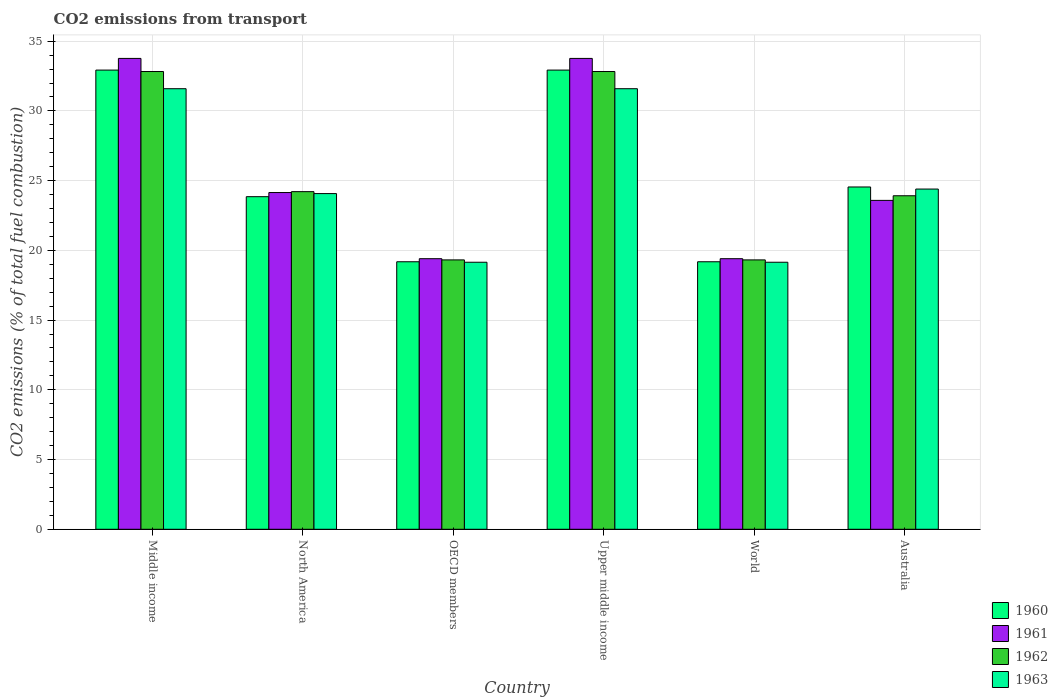How many different coloured bars are there?
Make the answer very short. 4. How many groups of bars are there?
Ensure brevity in your answer.  6. How many bars are there on the 2nd tick from the left?
Give a very brief answer. 4. What is the label of the 3rd group of bars from the left?
Your answer should be very brief. OECD members. In how many cases, is the number of bars for a given country not equal to the number of legend labels?
Offer a terse response. 0. What is the total CO2 emitted in 1962 in World?
Ensure brevity in your answer.  19.32. Across all countries, what is the maximum total CO2 emitted in 1962?
Offer a terse response. 32.82. Across all countries, what is the minimum total CO2 emitted in 1963?
Make the answer very short. 19.15. In which country was the total CO2 emitted in 1960 maximum?
Provide a succinct answer. Middle income. What is the total total CO2 emitted in 1961 in the graph?
Your response must be concise. 154.07. What is the difference between the total CO2 emitted in 1963 in North America and that in World?
Offer a very short reply. 4.92. What is the difference between the total CO2 emitted in 1963 in North America and the total CO2 emitted in 1960 in OECD members?
Keep it short and to the point. 4.89. What is the average total CO2 emitted in 1962 per country?
Give a very brief answer. 25.4. What is the difference between the total CO2 emitted of/in 1960 and total CO2 emitted of/in 1962 in World?
Your answer should be compact. -0.13. What is the ratio of the total CO2 emitted in 1963 in Middle income to that in OECD members?
Your response must be concise. 1.65. Is the total CO2 emitted in 1963 in Australia less than that in OECD members?
Your answer should be very brief. No. What is the difference between the highest and the second highest total CO2 emitted in 1961?
Your answer should be very brief. -9.62. What is the difference between the highest and the lowest total CO2 emitted in 1961?
Your answer should be very brief. 14.36. In how many countries, is the total CO2 emitted in 1962 greater than the average total CO2 emitted in 1962 taken over all countries?
Your response must be concise. 2. Is it the case that in every country, the sum of the total CO2 emitted in 1960 and total CO2 emitted in 1961 is greater than the sum of total CO2 emitted in 1963 and total CO2 emitted in 1962?
Provide a short and direct response. No. What does the 3rd bar from the right in World represents?
Give a very brief answer. 1961. How many bars are there?
Your answer should be very brief. 24. Are all the bars in the graph horizontal?
Provide a succinct answer. No. How many countries are there in the graph?
Offer a terse response. 6. What is the difference between two consecutive major ticks on the Y-axis?
Give a very brief answer. 5. Are the values on the major ticks of Y-axis written in scientific E-notation?
Provide a short and direct response. No. Does the graph contain any zero values?
Ensure brevity in your answer.  No. Where does the legend appear in the graph?
Provide a succinct answer. Bottom right. How many legend labels are there?
Ensure brevity in your answer.  4. What is the title of the graph?
Ensure brevity in your answer.  CO2 emissions from transport. What is the label or title of the Y-axis?
Give a very brief answer. CO2 emissions (% of total fuel combustion). What is the CO2 emissions (% of total fuel combustion) of 1960 in Middle income?
Your answer should be compact. 32.93. What is the CO2 emissions (% of total fuel combustion) in 1961 in Middle income?
Provide a short and direct response. 33.76. What is the CO2 emissions (% of total fuel combustion) of 1962 in Middle income?
Ensure brevity in your answer.  32.82. What is the CO2 emissions (% of total fuel combustion) of 1963 in Middle income?
Offer a terse response. 31.59. What is the CO2 emissions (% of total fuel combustion) of 1960 in North America?
Your answer should be compact. 23.85. What is the CO2 emissions (% of total fuel combustion) in 1961 in North America?
Offer a terse response. 24.15. What is the CO2 emissions (% of total fuel combustion) in 1962 in North America?
Your answer should be very brief. 24.21. What is the CO2 emissions (% of total fuel combustion) of 1963 in North America?
Give a very brief answer. 24.07. What is the CO2 emissions (% of total fuel combustion) in 1960 in OECD members?
Offer a very short reply. 19.18. What is the CO2 emissions (% of total fuel combustion) in 1961 in OECD members?
Keep it short and to the point. 19.4. What is the CO2 emissions (% of total fuel combustion) of 1962 in OECD members?
Your answer should be compact. 19.32. What is the CO2 emissions (% of total fuel combustion) of 1963 in OECD members?
Make the answer very short. 19.15. What is the CO2 emissions (% of total fuel combustion) of 1960 in Upper middle income?
Make the answer very short. 32.93. What is the CO2 emissions (% of total fuel combustion) in 1961 in Upper middle income?
Give a very brief answer. 33.76. What is the CO2 emissions (% of total fuel combustion) of 1962 in Upper middle income?
Give a very brief answer. 32.82. What is the CO2 emissions (% of total fuel combustion) in 1963 in Upper middle income?
Give a very brief answer. 31.59. What is the CO2 emissions (% of total fuel combustion) in 1960 in World?
Give a very brief answer. 19.18. What is the CO2 emissions (% of total fuel combustion) in 1961 in World?
Your answer should be compact. 19.4. What is the CO2 emissions (% of total fuel combustion) of 1962 in World?
Give a very brief answer. 19.32. What is the CO2 emissions (% of total fuel combustion) in 1963 in World?
Offer a terse response. 19.15. What is the CO2 emissions (% of total fuel combustion) in 1960 in Australia?
Give a very brief answer. 24.55. What is the CO2 emissions (% of total fuel combustion) in 1961 in Australia?
Provide a succinct answer. 23.59. What is the CO2 emissions (% of total fuel combustion) of 1962 in Australia?
Provide a short and direct response. 23.92. What is the CO2 emissions (% of total fuel combustion) in 1963 in Australia?
Offer a terse response. 24.4. Across all countries, what is the maximum CO2 emissions (% of total fuel combustion) in 1960?
Offer a terse response. 32.93. Across all countries, what is the maximum CO2 emissions (% of total fuel combustion) in 1961?
Give a very brief answer. 33.76. Across all countries, what is the maximum CO2 emissions (% of total fuel combustion) of 1962?
Your answer should be very brief. 32.82. Across all countries, what is the maximum CO2 emissions (% of total fuel combustion) of 1963?
Your answer should be compact. 31.59. Across all countries, what is the minimum CO2 emissions (% of total fuel combustion) in 1960?
Your response must be concise. 19.18. Across all countries, what is the minimum CO2 emissions (% of total fuel combustion) in 1961?
Offer a terse response. 19.4. Across all countries, what is the minimum CO2 emissions (% of total fuel combustion) in 1962?
Provide a succinct answer. 19.32. Across all countries, what is the minimum CO2 emissions (% of total fuel combustion) of 1963?
Your response must be concise. 19.15. What is the total CO2 emissions (% of total fuel combustion) of 1960 in the graph?
Make the answer very short. 152.62. What is the total CO2 emissions (% of total fuel combustion) in 1961 in the graph?
Make the answer very short. 154.07. What is the total CO2 emissions (% of total fuel combustion) in 1962 in the graph?
Give a very brief answer. 152.41. What is the total CO2 emissions (% of total fuel combustion) of 1963 in the graph?
Your answer should be compact. 149.95. What is the difference between the CO2 emissions (% of total fuel combustion) in 1960 in Middle income and that in North America?
Offer a terse response. 9.08. What is the difference between the CO2 emissions (% of total fuel combustion) of 1961 in Middle income and that in North America?
Your answer should be compact. 9.62. What is the difference between the CO2 emissions (% of total fuel combustion) in 1962 in Middle income and that in North America?
Make the answer very short. 8.61. What is the difference between the CO2 emissions (% of total fuel combustion) in 1963 in Middle income and that in North America?
Keep it short and to the point. 7.52. What is the difference between the CO2 emissions (% of total fuel combustion) in 1960 in Middle income and that in OECD members?
Give a very brief answer. 13.75. What is the difference between the CO2 emissions (% of total fuel combustion) in 1961 in Middle income and that in OECD members?
Ensure brevity in your answer.  14.36. What is the difference between the CO2 emissions (% of total fuel combustion) in 1962 in Middle income and that in OECD members?
Offer a terse response. 13.51. What is the difference between the CO2 emissions (% of total fuel combustion) in 1963 in Middle income and that in OECD members?
Offer a terse response. 12.44. What is the difference between the CO2 emissions (% of total fuel combustion) in 1960 in Middle income and that in Upper middle income?
Provide a short and direct response. 0. What is the difference between the CO2 emissions (% of total fuel combustion) of 1962 in Middle income and that in Upper middle income?
Your answer should be very brief. 0. What is the difference between the CO2 emissions (% of total fuel combustion) in 1960 in Middle income and that in World?
Make the answer very short. 13.75. What is the difference between the CO2 emissions (% of total fuel combustion) in 1961 in Middle income and that in World?
Offer a terse response. 14.36. What is the difference between the CO2 emissions (% of total fuel combustion) of 1962 in Middle income and that in World?
Provide a short and direct response. 13.51. What is the difference between the CO2 emissions (% of total fuel combustion) of 1963 in Middle income and that in World?
Offer a very short reply. 12.44. What is the difference between the CO2 emissions (% of total fuel combustion) of 1960 in Middle income and that in Australia?
Offer a terse response. 8.38. What is the difference between the CO2 emissions (% of total fuel combustion) of 1961 in Middle income and that in Australia?
Your answer should be compact. 10.18. What is the difference between the CO2 emissions (% of total fuel combustion) in 1962 in Middle income and that in Australia?
Keep it short and to the point. 8.91. What is the difference between the CO2 emissions (% of total fuel combustion) in 1963 in Middle income and that in Australia?
Your answer should be very brief. 7.2. What is the difference between the CO2 emissions (% of total fuel combustion) in 1960 in North America and that in OECD members?
Ensure brevity in your answer.  4.67. What is the difference between the CO2 emissions (% of total fuel combustion) in 1961 in North America and that in OECD members?
Make the answer very short. 4.74. What is the difference between the CO2 emissions (% of total fuel combustion) of 1962 in North America and that in OECD members?
Provide a short and direct response. 4.89. What is the difference between the CO2 emissions (% of total fuel combustion) of 1963 in North America and that in OECD members?
Your answer should be compact. 4.92. What is the difference between the CO2 emissions (% of total fuel combustion) in 1960 in North America and that in Upper middle income?
Your answer should be very brief. -9.08. What is the difference between the CO2 emissions (% of total fuel combustion) in 1961 in North America and that in Upper middle income?
Ensure brevity in your answer.  -9.62. What is the difference between the CO2 emissions (% of total fuel combustion) in 1962 in North America and that in Upper middle income?
Make the answer very short. -8.61. What is the difference between the CO2 emissions (% of total fuel combustion) of 1963 in North America and that in Upper middle income?
Your answer should be compact. -7.52. What is the difference between the CO2 emissions (% of total fuel combustion) in 1960 in North America and that in World?
Give a very brief answer. 4.67. What is the difference between the CO2 emissions (% of total fuel combustion) of 1961 in North America and that in World?
Provide a short and direct response. 4.74. What is the difference between the CO2 emissions (% of total fuel combustion) in 1962 in North America and that in World?
Give a very brief answer. 4.89. What is the difference between the CO2 emissions (% of total fuel combustion) in 1963 in North America and that in World?
Make the answer very short. 4.92. What is the difference between the CO2 emissions (% of total fuel combustion) in 1960 in North America and that in Australia?
Make the answer very short. -0.7. What is the difference between the CO2 emissions (% of total fuel combustion) of 1961 in North America and that in Australia?
Your answer should be very brief. 0.56. What is the difference between the CO2 emissions (% of total fuel combustion) of 1962 in North America and that in Australia?
Make the answer very short. 0.29. What is the difference between the CO2 emissions (% of total fuel combustion) in 1963 in North America and that in Australia?
Make the answer very short. -0.33. What is the difference between the CO2 emissions (% of total fuel combustion) of 1960 in OECD members and that in Upper middle income?
Your response must be concise. -13.75. What is the difference between the CO2 emissions (% of total fuel combustion) in 1961 in OECD members and that in Upper middle income?
Ensure brevity in your answer.  -14.36. What is the difference between the CO2 emissions (% of total fuel combustion) of 1962 in OECD members and that in Upper middle income?
Offer a very short reply. -13.51. What is the difference between the CO2 emissions (% of total fuel combustion) of 1963 in OECD members and that in Upper middle income?
Make the answer very short. -12.44. What is the difference between the CO2 emissions (% of total fuel combustion) in 1961 in OECD members and that in World?
Give a very brief answer. 0. What is the difference between the CO2 emissions (% of total fuel combustion) of 1962 in OECD members and that in World?
Your answer should be compact. 0. What is the difference between the CO2 emissions (% of total fuel combustion) in 1963 in OECD members and that in World?
Your answer should be compact. 0. What is the difference between the CO2 emissions (% of total fuel combustion) of 1960 in OECD members and that in Australia?
Keep it short and to the point. -5.36. What is the difference between the CO2 emissions (% of total fuel combustion) in 1961 in OECD members and that in Australia?
Your answer should be very brief. -4.18. What is the difference between the CO2 emissions (% of total fuel combustion) of 1962 in OECD members and that in Australia?
Your answer should be very brief. -4.6. What is the difference between the CO2 emissions (% of total fuel combustion) in 1963 in OECD members and that in Australia?
Offer a very short reply. -5.25. What is the difference between the CO2 emissions (% of total fuel combustion) of 1960 in Upper middle income and that in World?
Offer a very short reply. 13.75. What is the difference between the CO2 emissions (% of total fuel combustion) in 1961 in Upper middle income and that in World?
Your answer should be compact. 14.36. What is the difference between the CO2 emissions (% of total fuel combustion) in 1962 in Upper middle income and that in World?
Offer a very short reply. 13.51. What is the difference between the CO2 emissions (% of total fuel combustion) of 1963 in Upper middle income and that in World?
Offer a very short reply. 12.44. What is the difference between the CO2 emissions (% of total fuel combustion) of 1960 in Upper middle income and that in Australia?
Provide a short and direct response. 8.38. What is the difference between the CO2 emissions (% of total fuel combustion) in 1961 in Upper middle income and that in Australia?
Make the answer very short. 10.18. What is the difference between the CO2 emissions (% of total fuel combustion) in 1962 in Upper middle income and that in Australia?
Your answer should be compact. 8.91. What is the difference between the CO2 emissions (% of total fuel combustion) of 1963 in Upper middle income and that in Australia?
Your response must be concise. 7.2. What is the difference between the CO2 emissions (% of total fuel combustion) in 1960 in World and that in Australia?
Provide a short and direct response. -5.36. What is the difference between the CO2 emissions (% of total fuel combustion) in 1961 in World and that in Australia?
Offer a terse response. -4.18. What is the difference between the CO2 emissions (% of total fuel combustion) of 1962 in World and that in Australia?
Provide a short and direct response. -4.6. What is the difference between the CO2 emissions (% of total fuel combustion) of 1963 in World and that in Australia?
Your response must be concise. -5.25. What is the difference between the CO2 emissions (% of total fuel combustion) in 1960 in Middle income and the CO2 emissions (% of total fuel combustion) in 1961 in North America?
Offer a terse response. 8.78. What is the difference between the CO2 emissions (% of total fuel combustion) in 1960 in Middle income and the CO2 emissions (% of total fuel combustion) in 1962 in North America?
Your response must be concise. 8.72. What is the difference between the CO2 emissions (% of total fuel combustion) in 1960 in Middle income and the CO2 emissions (% of total fuel combustion) in 1963 in North America?
Your answer should be very brief. 8.86. What is the difference between the CO2 emissions (% of total fuel combustion) in 1961 in Middle income and the CO2 emissions (% of total fuel combustion) in 1962 in North America?
Your answer should be compact. 9.55. What is the difference between the CO2 emissions (% of total fuel combustion) in 1961 in Middle income and the CO2 emissions (% of total fuel combustion) in 1963 in North America?
Your answer should be very brief. 9.69. What is the difference between the CO2 emissions (% of total fuel combustion) of 1962 in Middle income and the CO2 emissions (% of total fuel combustion) of 1963 in North America?
Ensure brevity in your answer.  8.75. What is the difference between the CO2 emissions (% of total fuel combustion) of 1960 in Middle income and the CO2 emissions (% of total fuel combustion) of 1961 in OECD members?
Your answer should be very brief. 13.53. What is the difference between the CO2 emissions (% of total fuel combustion) in 1960 in Middle income and the CO2 emissions (% of total fuel combustion) in 1962 in OECD members?
Keep it short and to the point. 13.61. What is the difference between the CO2 emissions (% of total fuel combustion) of 1960 in Middle income and the CO2 emissions (% of total fuel combustion) of 1963 in OECD members?
Give a very brief answer. 13.78. What is the difference between the CO2 emissions (% of total fuel combustion) of 1961 in Middle income and the CO2 emissions (% of total fuel combustion) of 1962 in OECD members?
Make the answer very short. 14.45. What is the difference between the CO2 emissions (% of total fuel combustion) of 1961 in Middle income and the CO2 emissions (% of total fuel combustion) of 1963 in OECD members?
Your answer should be compact. 14.62. What is the difference between the CO2 emissions (% of total fuel combustion) of 1962 in Middle income and the CO2 emissions (% of total fuel combustion) of 1963 in OECD members?
Your answer should be very brief. 13.68. What is the difference between the CO2 emissions (% of total fuel combustion) of 1960 in Middle income and the CO2 emissions (% of total fuel combustion) of 1961 in Upper middle income?
Provide a succinct answer. -0.84. What is the difference between the CO2 emissions (% of total fuel combustion) of 1960 in Middle income and the CO2 emissions (% of total fuel combustion) of 1962 in Upper middle income?
Your response must be concise. 0.1. What is the difference between the CO2 emissions (% of total fuel combustion) of 1960 in Middle income and the CO2 emissions (% of total fuel combustion) of 1963 in Upper middle income?
Keep it short and to the point. 1.34. What is the difference between the CO2 emissions (% of total fuel combustion) of 1961 in Middle income and the CO2 emissions (% of total fuel combustion) of 1962 in Upper middle income?
Your answer should be very brief. 0.94. What is the difference between the CO2 emissions (% of total fuel combustion) in 1961 in Middle income and the CO2 emissions (% of total fuel combustion) in 1963 in Upper middle income?
Your answer should be compact. 2.17. What is the difference between the CO2 emissions (% of total fuel combustion) of 1962 in Middle income and the CO2 emissions (% of total fuel combustion) of 1963 in Upper middle income?
Provide a succinct answer. 1.23. What is the difference between the CO2 emissions (% of total fuel combustion) in 1960 in Middle income and the CO2 emissions (% of total fuel combustion) in 1961 in World?
Ensure brevity in your answer.  13.53. What is the difference between the CO2 emissions (% of total fuel combustion) of 1960 in Middle income and the CO2 emissions (% of total fuel combustion) of 1962 in World?
Offer a very short reply. 13.61. What is the difference between the CO2 emissions (% of total fuel combustion) in 1960 in Middle income and the CO2 emissions (% of total fuel combustion) in 1963 in World?
Give a very brief answer. 13.78. What is the difference between the CO2 emissions (% of total fuel combustion) of 1961 in Middle income and the CO2 emissions (% of total fuel combustion) of 1962 in World?
Provide a succinct answer. 14.45. What is the difference between the CO2 emissions (% of total fuel combustion) in 1961 in Middle income and the CO2 emissions (% of total fuel combustion) in 1963 in World?
Your answer should be compact. 14.62. What is the difference between the CO2 emissions (% of total fuel combustion) in 1962 in Middle income and the CO2 emissions (% of total fuel combustion) in 1963 in World?
Provide a succinct answer. 13.68. What is the difference between the CO2 emissions (% of total fuel combustion) of 1960 in Middle income and the CO2 emissions (% of total fuel combustion) of 1961 in Australia?
Your answer should be very brief. 9.34. What is the difference between the CO2 emissions (% of total fuel combustion) of 1960 in Middle income and the CO2 emissions (% of total fuel combustion) of 1962 in Australia?
Your answer should be very brief. 9.01. What is the difference between the CO2 emissions (% of total fuel combustion) in 1960 in Middle income and the CO2 emissions (% of total fuel combustion) in 1963 in Australia?
Provide a succinct answer. 8.53. What is the difference between the CO2 emissions (% of total fuel combustion) of 1961 in Middle income and the CO2 emissions (% of total fuel combustion) of 1962 in Australia?
Provide a short and direct response. 9.85. What is the difference between the CO2 emissions (% of total fuel combustion) of 1961 in Middle income and the CO2 emissions (% of total fuel combustion) of 1963 in Australia?
Provide a short and direct response. 9.37. What is the difference between the CO2 emissions (% of total fuel combustion) of 1962 in Middle income and the CO2 emissions (% of total fuel combustion) of 1963 in Australia?
Your answer should be very brief. 8.43. What is the difference between the CO2 emissions (% of total fuel combustion) in 1960 in North America and the CO2 emissions (% of total fuel combustion) in 1961 in OECD members?
Keep it short and to the point. 4.45. What is the difference between the CO2 emissions (% of total fuel combustion) in 1960 in North America and the CO2 emissions (% of total fuel combustion) in 1962 in OECD members?
Provide a short and direct response. 4.53. What is the difference between the CO2 emissions (% of total fuel combustion) of 1960 in North America and the CO2 emissions (% of total fuel combustion) of 1963 in OECD members?
Offer a terse response. 4.7. What is the difference between the CO2 emissions (% of total fuel combustion) in 1961 in North America and the CO2 emissions (% of total fuel combustion) in 1962 in OECD members?
Ensure brevity in your answer.  4.83. What is the difference between the CO2 emissions (% of total fuel combustion) of 1961 in North America and the CO2 emissions (% of total fuel combustion) of 1963 in OECD members?
Your answer should be compact. 5. What is the difference between the CO2 emissions (% of total fuel combustion) in 1962 in North America and the CO2 emissions (% of total fuel combustion) in 1963 in OECD members?
Offer a very short reply. 5.06. What is the difference between the CO2 emissions (% of total fuel combustion) of 1960 in North America and the CO2 emissions (% of total fuel combustion) of 1961 in Upper middle income?
Ensure brevity in your answer.  -9.91. What is the difference between the CO2 emissions (% of total fuel combustion) of 1960 in North America and the CO2 emissions (% of total fuel combustion) of 1962 in Upper middle income?
Your answer should be very brief. -8.97. What is the difference between the CO2 emissions (% of total fuel combustion) in 1960 in North America and the CO2 emissions (% of total fuel combustion) in 1963 in Upper middle income?
Keep it short and to the point. -7.74. What is the difference between the CO2 emissions (% of total fuel combustion) in 1961 in North America and the CO2 emissions (% of total fuel combustion) in 1962 in Upper middle income?
Offer a terse response. -8.68. What is the difference between the CO2 emissions (% of total fuel combustion) in 1961 in North America and the CO2 emissions (% of total fuel combustion) in 1963 in Upper middle income?
Make the answer very short. -7.45. What is the difference between the CO2 emissions (% of total fuel combustion) in 1962 in North America and the CO2 emissions (% of total fuel combustion) in 1963 in Upper middle income?
Give a very brief answer. -7.38. What is the difference between the CO2 emissions (% of total fuel combustion) in 1960 in North America and the CO2 emissions (% of total fuel combustion) in 1961 in World?
Your response must be concise. 4.45. What is the difference between the CO2 emissions (% of total fuel combustion) of 1960 in North America and the CO2 emissions (% of total fuel combustion) of 1962 in World?
Keep it short and to the point. 4.53. What is the difference between the CO2 emissions (% of total fuel combustion) of 1960 in North America and the CO2 emissions (% of total fuel combustion) of 1963 in World?
Offer a very short reply. 4.7. What is the difference between the CO2 emissions (% of total fuel combustion) in 1961 in North America and the CO2 emissions (% of total fuel combustion) in 1962 in World?
Give a very brief answer. 4.83. What is the difference between the CO2 emissions (% of total fuel combustion) of 1961 in North America and the CO2 emissions (% of total fuel combustion) of 1963 in World?
Keep it short and to the point. 5. What is the difference between the CO2 emissions (% of total fuel combustion) of 1962 in North America and the CO2 emissions (% of total fuel combustion) of 1963 in World?
Offer a terse response. 5.06. What is the difference between the CO2 emissions (% of total fuel combustion) in 1960 in North America and the CO2 emissions (% of total fuel combustion) in 1961 in Australia?
Your answer should be very brief. 0.27. What is the difference between the CO2 emissions (% of total fuel combustion) of 1960 in North America and the CO2 emissions (% of total fuel combustion) of 1962 in Australia?
Give a very brief answer. -0.07. What is the difference between the CO2 emissions (% of total fuel combustion) in 1960 in North America and the CO2 emissions (% of total fuel combustion) in 1963 in Australia?
Keep it short and to the point. -0.55. What is the difference between the CO2 emissions (% of total fuel combustion) in 1961 in North America and the CO2 emissions (% of total fuel combustion) in 1962 in Australia?
Ensure brevity in your answer.  0.23. What is the difference between the CO2 emissions (% of total fuel combustion) of 1961 in North America and the CO2 emissions (% of total fuel combustion) of 1963 in Australia?
Your answer should be very brief. -0.25. What is the difference between the CO2 emissions (% of total fuel combustion) of 1962 in North America and the CO2 emissions (% of total fuel combustion) of 1963 in Australia?
Keep it short and to the point. -0.19. What is the difference between the CO2 emissions (% of total fuel combustion) in 1960 in OECD members and the CO2 emissions (% of total fuel combustion) in 1961 in Upper middle income?
Keep it short and to the point. -14.58. What is the difference between the CO2 emissions (% of total fuel combustion) of 1960 in OECD members and the CO2 emissions (% of total fuel combustion) of 1962 in Upper middle income?
Ensure brevity in your answer.  -13.64. What is the difference between the CO2 emissions (% of total fuel combustion) in 1960 in OECD members and the CO2 emissions (% of total fuel combustion) in 1963 in Upper middle income?
Your response must be concise. -12.41. What is the difference between the CO2 emissions (% of total fuel combustion) in 1961 in OECD members and the CO2 emissions (% of total fuel combustion) in 1962 in Upper middle income?
Ensure brevity in your answer.  -13.42. What is the difference between the CO2 emissions (% of total fuel combustion) in 1961 in OECD members and the CO2 emissions (% of total fuel combustion) in 1963 in Upper middle income?
Provide a succinct answer. -12.19. What is the difference between the CO2 emissions (% of total fuel combustion) in 1962 in OECD members and the CO2 emissions (% of total fuel combustion) in 1963 in Upper middle income?
Offer a very short reply. -12.28. What is the difference between the CO2 emissions (% of total fuel combustion) in 1960 in OECD members and the CO2 emissions (% of total fuel combustion) in 1961 in World?
Make the answer very short. -0.22. What is the difference between the CO2 emissions (% of total fuel combustion) in 1960 in OECD members and the CO2 emissions (% of total fuel combustion) in 1962 in World?
Your answer should be compact. -0.13. What is the difference between the CO2 emissions (% of total fuel combustion) in 1960 in OECD members and the CO2 emissions (% of total fuel combustion) in 1963 in World?
Keep it short and to the point. 0.03. What is the difference between the CO2 emissions (% of total fuel combustion) in 1961 in OECD members and the CO2 emissions (% of total fuel combustion) in 1962 in World?
Your answer should be compact. 0.09. What is the difference between the CO2 emissions (% of total fuel combustion) of 1961 in OECD members and the CO2 emissions (% of total fuel combustion) of 1963 in World?
Offer a very short reply. 0.25. What is the difference between the CO2 emissions (% of total fuel combustion) in 1962 in OECD members and the CO2 emissions (% of total fuel combustion) in 1963 in World?
Ensure brevity in your answer.  0.17. What is the difference between the CO2 emissions (% of total fuel combustion) in 1960 in OECD members and the CO2 emissions (% of total fuel combustion) in 1961 in Australia?
Ensure brevity in your answer.  -4.4. What is the difference between the CO2 emissions (% of total fuel combustion) in 1960 in OECD members and the CO2 emissions (% of total fuel combustion) in 1962 in Australia?
Make the answer very short. -4.73. What is the difference between the CO2 emissions (% of total fuel combustion) in 1960 in OECD members and the CO2 emissions (% of total fuel combustion) in 1963 in Australia?
Your answer should be compact. -5.21. What is the difference between the CO2 emissions (% of total fuel combustion) of 1961 in OECD members and the CO2 emissions (% of total fuel combustion) of 1962 in Australia?
Keep it short and to the point. -4.51. What is the difference between the CO2 emissions (% of total fuel combustion) in 1961 in OECD members and the CO2 emissions (% of total fuel combustion) in 1963 in Australia?
Make the answer very short. -4.99. What is the difference between the CO2 emissions (% of total fuel combustion) of 1962 in OECD members and the CO2 emissions (% of total fuel combustion) of 1963 in Australia?
Your answer should be compact. -5.08. What is the difference between the CO2 emissions (% of total fuel combustion) of 1960 in Upper middle income and the CO2 emissions (% of total fuel combustion) of 1961 in World?
Make the answer very short. 13.53. What is the difference between the CO2 emissions (% of total fuel combustion) in 1960 in Upper middle income and the CO2 emissions (% of total fuel combustion) in 1962 in World?
Make the answer very short. 13.61. What is the difference between the CO2 emissions (% of total fuel combustion) in 1960 in Upper middle income and the CO2 emissions (% of total fuel combustion) in 1963 in World?
Offer a very short reply. 13.78. What is the difference between the CO2 emissions (% of total fuel combustion) in 1961 in Upper middle income and the CO2 emissions (% of total fuel combustion) in 1962 in World?
Your answer should be very brief. 14.45. What is the difference between the CO2 emissions (% of total fuel combustion) in 1961 in Upper middle income and the CO2 emissions (% of total fuel combustion) in 1963 in World?
Give a very brief answer. 14.62. What is the difference between the CO2 emissions (% of total fuel combustion) in 1962 in Upper middle income and the CO2 emissions (% of total fuel combustion) in 1963 in World?
Provide a short and direct response. 13.68. What is the difference between the CO2 emissions (% of total fuel combustion) in 1960 in Upper middle income and the CO2 emissions (% of total fuel combustion) in 1961 in Australia?
Ensure brevity in your answer.  9.34. What is the difference between the CO2 emissions (% of total fuel combustion) of 1960 in Upper middle income and the CO2 emissions (% of total fuel combustion) of 1962 in Australia?
Provide a succinct answer. 9.01. What is the difference between the CO2 emissions (% of total fuel combustion) of 1960 in Upper middle income and the CO2 emissions (% of total fuel combustion) of 1963 in Australia?
Ensure brevity in your answer.  8.53. What is the difference between the CO2 emissions (% of total fuel combustion) in 1961 in Upper middle income and the CO2 emissions (% of total fuel combustion) in 1962 in Australia?
Offer a very short reply. 9.85. What is the difference between the CO2 emissions (% of total fuel combustion) of 1961 in Upper middle income and the CO2 emissions (% of total fuel combustion) of 1963 in Australia?
Ensure brevity in your answer.  9.37. What is the difference between the CO2 emissions (% of total fuel combustion) of 1962 in Upper middle income and the CO2 emissions (% of total fuel combustion) of 1963 in Australia?
Make the answer very short. 8.43. What is the difference between the CO2 emissions (% of total fuel combustion) in 1960 in World and the CO2 emissions (% of total fuel combustion) in 1961 in Australia?
Provide a succinct answer. -4.4. What is the difference between the CO2 emissions (% of total fuel combustion) in 1960 in World and the CO2 emissions (% of total fuel combustion) in 1962 in Australia?
Offer a terse response. -4.73. What is the difference between the CO2 emissions (% of total fuel combustion) in 1960 in World and the CO2 emissions (% of total fuel combustion) in 1963 in Australia?
Offer a terse response. -5.21. What is the difference between the CO2 emissions (% of total fuel combustion) in 1961 in World and the CO2 emissions (% of total fuel combustion) in 1962 in Australia?
Give a very brief answer. -4.51. What is the difference between the CO2 emissions (% of total fuel combustion) in 1961 in World and the CO2 emissions (% of total fuel combustion) in 1963 in Australia?
Offer a terse response. -4.99. What is the difference between the CO2 emissions (% of total fuel combustion) in 1962 in World and the CO2 emissions (% of total fuel combustion) in 1963 in Australia?
Your answer should be compact. -5.08. What is the average CO2 emissions (% of total fuel combustion) in 1960 per country?
Make the answer very short. 25.44. What is the average CO2 emissions (% of total fuel combustion) of 1961 per country?
Your answer should be very brief. 25.68. What is the average CO2 emissions (% of total fuel combustion) in 1962 per country?
Your response must be concise. 25.4. What is the average CO2 emissions (% of total fuel combustion) of 1963 per country?
Keep it short and to the point. 24.99. What is the difference between the CO2 emissions (% of total fuel combustion) in 1960 and CO2 emissions (% of total fuel combustion) in 1961 in Middle income?
Offer a terse response. -0.84. What is the difference between the CO2 emissions (% of total fuel combustion) in 1960 and CO2 emissions (% of total fuel combustion) in 1962 in Middle income?
Make the answer very short. 0.1. What is the difference between the CO2 emissions (% of total fuel combustion) in 1960 and CO2 emissions (% of total fuel combustion) in 1963 in Middle income?
Offer a very short reply. 1.34. What is the difference between the CO2 emissions (% of total fuel combustion) of 1961 and CO2 emissions (% of total fuel combustion) of 1962 in Middle income?
Offer a terse response. 0.94. What is the difference between the CO2 emissions (% of total fuel combustion) of 1961 and CO2 emissions (% of total fuel combustion) of 1963 in Middle income?
Offer a terse response. 2.17. What is the difference between the CO2 emissions (% of total fuel combustion) of 1962 and CO2 emissions (% of total fuel combustion) of 1963 in Middle income?
Provide a short and direct response. 1.23. What is the difference between the CO2 emissions (% of total fuel combustion) of 1960 and CO2 emissions (% of total fuel combustion) of 1961 in North America?
Your response must be concise. -0.3. What is the difference between the CO2 emissions (% of total fuel combustion) in 1960 and CO2 emissions (% of total fuel combustion) in 1962 in North America?
Your answer should be compact. -0.36. What is the difference between the CO2 emissions (% of total fuel combustion) of 1960 and CO2 emissions (% of total fuel combustion) of 1963 in North America?
Your response must be concise. -0.22. What is the difference between the CO2 emissions (% of total fuel combustion) of 1961 and CO2 emissions (% of total fuel combustion) of 1962 in North America?
Provide a succinct answer. -0.06. What is the difference between the CO2 emissions (% of total fuel combustion) of 1961 and CO2 emissions (% of total fuel combustion) of 1963 in North America?
Your response must be concise. 0.07. What is the difference between the CO2 emissions (% of total fuel combustion) of 1962 and CO2 emissions (% of total fuel combustion) of 1963 in North America?
Make the answer very short. 0.14. What is the difference between the CO2 emissions (% of total fuel combustion) in 1960 and CO2 emissions (% of total fuel combustion) in 1961 in OECD members?
Your answer should be compact. -0.22. What is the difference between the CO2 emissions (% of total fuel combustion) in 1960 and CO2 emissions (% of total fuel combustion) in 1962 in OECD members?
Provide a succinct answer. -0.13. What is the difference between the CO2 emissions (% of total fuel combustion) in 1960 and CO2 emissions (% of total fuel combustion) in 1963 in OECD members?
Your response must be concise. 0.03. What is the difference between the CO2 emissions (% of total fuel combustion) in 1961 and CO2 emissions (% of total fuel combustion) in 1962 in OECD members?
Keep it short and to the point. 0.09. What is the difference between the CO2 emissions (% of total fuel combustion) in 1961 and CO2 emissions (% of total fuel combustion) in 1963 in OECD members?
Make the answer very short. 0.25. What is the difference between the CO2 emissions (% of total fuel combustion) in 1962 and CO2 emissions (% of total fuel combustion) in 1963 in OECD members?
Make the answer very short. 0.17. What is the difference between the CO2 emissions (% of total fuel combustion) in 1960 and CO2 emissions (% of total fuel combustion) in 1961 in Upper middle income?
Offer a terse response. -0.84. What is the difference between the CO2 emissions (% of total fuel combustion) in 1960 and CO2 emissions (% of total fuel combustion) in 1962 in Upper middle income?
Offer a very short reply. 0.1. What is the difference between the CO2 emissions (% of total fuel combustion) of 1960 and CO2 emissions (% of total fuel combustion) of 1963 in Upper middle income?
Your response must be concise. 1.34. What is the difference between the CO2 emissions (% of total fuel combustion) in 1961 and CO2 emissions (% of total fuel combustion) in 1962 in Upper middle income?
Offer a very short reply. 0.94. What is the difference between the CO2 emissions (% of total fuel combustion) in 1961 and CO2 emissions (% of total fuel combustion) in 1963 in Upper middle income?
Make the answer very short. 2.17. What is the difference between the CO2 emissions (% of total fuel combustion) in 1962 and CO2 emissions (% of total fuel combustion) in 1963 in Upper middle income?
Your answer should be very brief. 1.23. What is the difference between the CO2 emissions (% of total fuel combustion) in 1960 and CO2 emissions (% of total fuel combustion) in 1961 in World?
Your response must be concise. -0.22. What is the difference between the CO2 emissions (% of total fuel combustion) of 1960 and CO2 emissions (% of total fuel combustion) of 1962 in World?
Offer a very short reply. -0.13. What is the difference between the CO2 emissions (% of total fuel combustion) in 1960 and CO2 emissions (% of total fuel combustion) in 1963 in World?
Provide a succinct answer. 0.03. What is the difference between the CO2 emissions (% of total fuel combustion) in 1961 and CO2 emissions (% of total fuel combustion) in 1962 in World?
Offer a very short reply. 0.09. What is the difference between the CO2 emissions (% of total fuel combustion) in 1961 and CO2 emissions (% of total fuel combustion) in 1963 in World?
Your response must be concise. 0.25. What is the difference between the CO2 emissions (% of total fuel combustion) in 1962 and CO2 emissions (% of total fuel combustion) in 1963 in World?
Provide a succinct answer. 0.17. What is the difference between the CO2 emissions (% of total fuel combustion) in 1960 and CO2 emissions (% of total fuel combustion) in 1961 in Australia?
Your answer should be very brief. 0.96. What is the difference between the CO2 emissions (% of total fuel combustion) in 1960 and CO2 emissions (% of total fuel combustion) in 1962 in Australia?
Your answer should be compact. 0.63. What is the difference between the CO2 emissions (% of total fuel combustion) of 1960 and CO2 emissions (% of total fuel combustion) of 1963 in Australia?
Offer a very short reply. 0.15. What is the difference between the CO2 emissions (% of total fuel combustion) of 1961 and CO2 emissions (% of total fuel combustion) of 1962 in Australia?
Provide a short and direct response. -0.33. What is the difference between the CO2 emissions (% of total fuel combustion) of 1961 and CO2 emissions (% of total fuel combustion) of 1963 in Australia?
Keep it short and to the point. -0.81. What is the difference between the CO2 emissions (% of total fuel combustion) in 1962 and CO2 emissions (% of total fuel combustion) in 1963 in Australia?
Give a very brief answer. -0.48. What is the ratio of the CO2 emissions (% of total fuel combustion) in 1960 in Middle income to that in North America?
Offer a terse response. 1.38. What is the ratio of the CO2 emissions (% of total fuel combustion) of 1961 in Middle income to that in North America?
Provide a short and direct response. 1.4. What is the ratio of the CO2 emissions (% of total fuel combustion) of 1962 in Middle income to that in North America?
Offer a very short reply. 1.36. What is the ratio of the CO2 emissions (% of total fuel combustion) in 1963 in Middle income to that in North America?
Your answer should be compact. 1.31. What is the ratio of the CO2 emissions (% of total fuel combustion) in 1960 in Middle income to that in OECD members?
Make the answer very short. 1.72. What is the ratio of the CO2 emissions (% of total fuel combustion) in 1961 in Middle income to that in OECD members?
Provide a succinct answer. 1.74. What is the ratio of the CO2 emissions (% of total fuel combustion) in 1962 in Middle income to that in OECD members?
Ensure brevity in your answer.  1.7. What is the ratio of the CO2 emissions (% of total fuel combustion) in 1963 in Middle income to that in OECD members?
Provide a succinct answer. 1.65. What is the ratio of the CO2 emissions (% of total fuel combustion) of 1960 in Middle income to that in Upper middle income?
Provide a short and direct response. 1. What is the ratio of the CO2 emissions (% of total fuel combustion) of 1961 in Middle income to that in Upper middle income?
Offer a terse response. 1. What is the ratio of the CO2 emissions (% of total fuel combustion) of 1963 in Middle income to that in Upper middle income?
Keep it short and to the point. 1. What is the ratio of the CO2 emissions (% of total fuel combustion) of 1960 in Middle income to that in World?
Provide a succinct answer. 1.72. What is the ratio of the CO2 emissions (% of total fuel combustion) in 1961 in Middle income to that in World?
Give a very brief answer. 1.74. What is the ratio of the CO2 emissions (% of total fuel combustion) in 1962 in Middle income to that in World?
Provide a succinct answer. 1.7. What is the ratio of the CO2 emissions (% of total fuel combustion) in 1963 in Middle income to that in World?
Keep it short and to the point. 1.65. What is the ratio of the CO2 emissions (% of total fuel combustion) in 1960 in Middle income to that in Australia?
Keep it short and to the point. 1.34. What is the ratio of the CO2 emissions (% of total fuel combustion) in 1961 in Middle income to that in Australia?
Provide a succinct answer. 1.43. What is the ratio of the CO2 emissions (% of total fuel combustion) of 1962 in Middle income to that in Australia?
Keep it short and to the point. 1.37. What is the ratio of the CO2 emissions (% of total fuel combustion) of 1963 in Middle income to that in Australia?
Ensure brevity in your answer.  1.29. What is the ratio of the CO2 emissions (% of total fuel combustion) in 1960 in North America to that in OECD members?
Your answer should be very brief. 1.24. What is the ratio of the CO2 emissions (% of total fuel combustion) of 1961 in North America to that in OECD members?
Ensure brevity in your answer.  1.24. What is the ratio of the CO2 emissions (% of total fuel combustion) of 1962 in North America to that in OECD members?
Your response must be concise. 1.25. What is the ratio of the CO2 emissions (% of total fuel combustion) in 1963 in North America to that in OECD members?
Give a very brief answer. 1.26. What is the ratio of the CO2 emissions (% of total fuel combustion) of 1960 in North America to that in Upper middle income?
Offer a very short reply. 0.72. What is the ratio of the CO2 emissions (% of total fuel combustion) in 1961 in North America to that in Upper middle income?
Ensure brevity in your answer.  0.72. What is the ratio of the CO2 emissions (% of total fuel combustion) in 1962 in North America to that in Upper middle income?
Give a very brief answer. 0.74. What is the ratio of the CO2 emissions (% of total fuel combustion) of 1963 in North America to that in Upper middle income?
Give a very brief answer. 0.76. What is the ratio of the CO2 emissions (% of total fuel combustion) in 1960 in North America to that in World?
Give a very brief answer. 1.24. What is the ratio of the CO2 emissions (% of total fuel combustion) of 1961 in North America to that in World?
Your answer should be compact. 1.24. What is the ratio of the CO2 emissions (% of total fuel combustion) of 1962 in North America to that in World?
Provide a succinct answer. 1.25. What is the ratio of the CO2 emissions (% of total fuel combustion) of 1963 in North America to that in World?
Give a very brief answer. 1.26. What is the ratio of the CO2 emissions (% of total fuel combustion) of 1960 in North America to that in Australia?
Offer a terse response. 0.97. What is the ratio of the CO2 emissions (% of total fuel combustion) of 1961 in North America to that in Australia?
Your answer should be very brief. 1.02. What is the ratio of the CO2 emissions (% of total fuel combustion) in 1962 in North America to that in Australia?
Offer a terse response. 1.01. What is the ratio of the CO2 emissions (% of total fuel combustion) of 1963 in North America to that in Australia?
Make the answer very short. 0.99. What is the ratio of the CO2 emissions (% of total fuel combustion) of 1960 in OECD members to that in Upper middle income?
Keep it short and to the point. 0.58. What is the ratio of the CO2 emissions (% of total fuel combustion) of 1961 in OECD members to that in Upper middle income?
Your answer should be compact. 0.57. What is the ratio of the CO2 emissions (% of total fuel combustion) of 1962 in OECD members to that in Upper middle income?
Offer a terse response. 0.59. What is the ratio of the CO2 emissions (% of total fuel combustion) in 1963 in OECD members to that in Upper middle income?
Your answer should be compact. 0.61. What is the ratio of the CO2 emissions (% of total fuel combustion) of 1960 in OECD members to that in World?
Make the answer very short. 1. What is the ratio of the CO2 emissions (% of total fuel combustion) in 1961 in OECD members to that in World?
Provide a short and direct response. 1. What is the ratio of the CO2 emissions (% of total fuel combustion) in 1962 in OECD members to that in World?
Provide a succinct answer. 1. What is the ratio of the CO2 emissions (% of total fuel combustion) in 1960 in OECD members to that in Australia?
Your response must be concise. 0.78. What is the ratio of the CO2 emissions (% of total fuel combustion) in 1961 in OECD members to that in Australia?
Give a very brief answer. 0.82. What is the ratio of the CO2 emissions (% of total fuel combustion) of 1962 in OECD members to that in Australia?
Your answer should be very brief. 0.81. What is the ratio of the CO2 emissions (% of total fuel combustion) in 1963 in OECD members to that in Australia?
Your answer should be compact. 0.78. What is the ratio of the CO2 emissions (% of total fuel combustion) in 1960 in Upper middle income to that in World?
Make the answer very short. 1.72. What is the ratio of the CO2 emissions (% of total fuel combustion) of 1961 in Upper middle income to that in World?
Ensure brevity in your answer.  1.74. What is the ratio of the CO2 emissions (% of total fuel combustion) of 1962 in Upper middle income to that in World?
Offer a very short reply. 1.7. What is the ratio of the CO2 emissions (% of total fuel combustion) of 1963 in Upper middle income to that in World?
Offer a terse response. 1.65. What is the ratio of the CO2 emissions (% of total fuel combustion) in 1960 in Upper middle income to that in Australia?
Offer a terse response. 1.34. What is the ratio of the CO2 emissions (% of total fuel combustion) in 1961 in Upper middle income to that in Australia?
Give a very brief answer. 1.43. What is the ratio of the CO2 emissions (% of total fuel combustion) in 1962 in Upper middle income to that in Australia?
Give a very brief answer. 1.37. What is the ratio of the CO2 emissions (% of total fuel combustion) of 1963 in Upper middle income to that in Australia?
Ensure brevity in your answer.  1.29. What is the ratio of the CO2 emissions (% of total fuel combustion) of 1960 in World to that in Australia?
Offer a very short reply. 0.78. What is the ratio of the CO2 emissions (% of total fuel combustion) in 1961 in World to that in Australia?
Keep it short and to the point. 0.82. What is the ratio of the CO2 emissions (% of total fuel combustion) of 1962 in World to that in Australia?
Offer a terse response. 0.81. What is the ratio of the CO2 emissions (% of total fuel combustion) in 1963 in World to that in Australia?
Give a very brief answer. 0.78. What is the difference between the highest and the second highest CO2 emissions (% of total fuel combustion) of 1961?
Provide a short and direct response. 0. What is the difference between the highest and the lowest CO2 emissions (% of total fuel combustion) of 1960?
Offer a very short reply. 13.75. What is the difference between the highest and the lowest CO2 emissions (% of total fuel combustion) in 1961?
Keep it short and to the point. 14.36. What is the difference between the highest and the lowest CO2 emissions (% of total fuel combustion) in 1962?
Keep it short and to the point. 13.51. What is the difference between the highest and the lowest CO2 emissions (% of total fuel combustion) in 1963?
Your response must be concise. 12.44. 